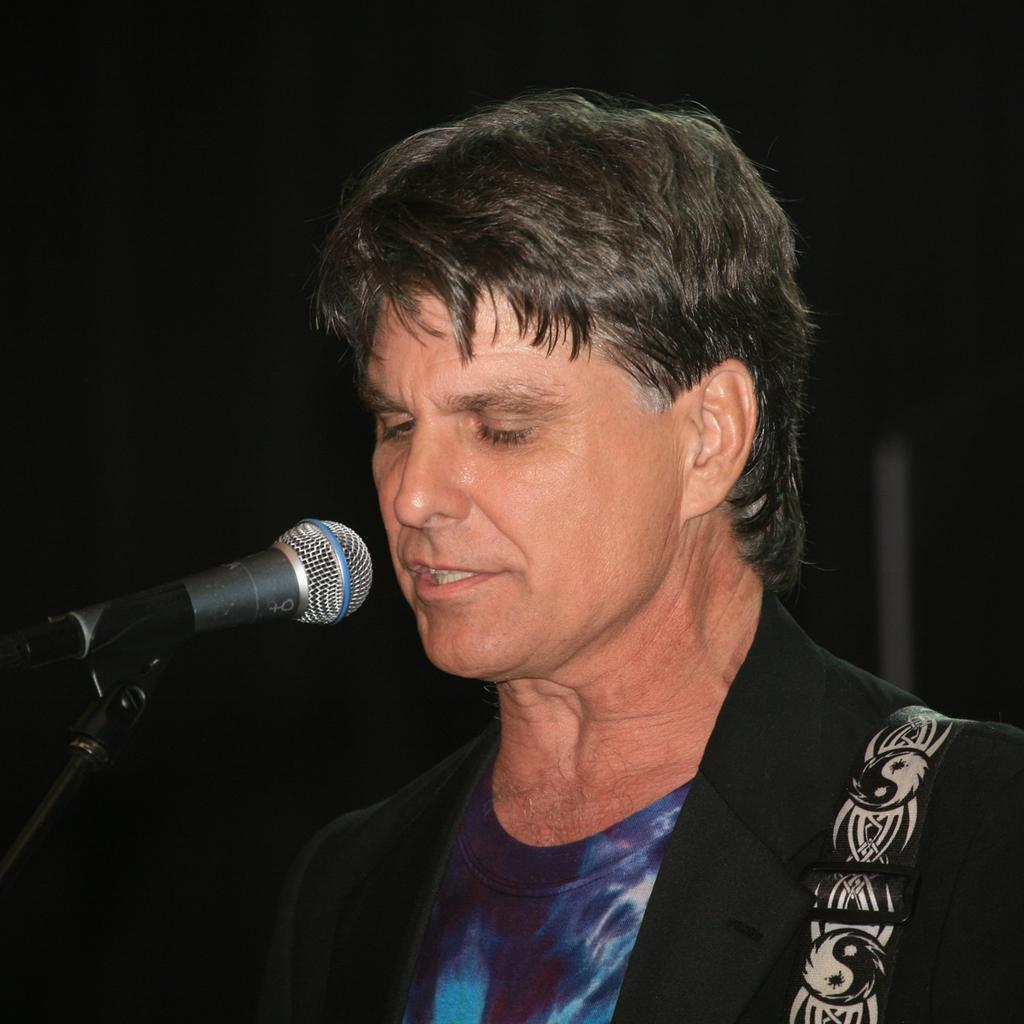How would you summarize this image in a sentence or two? In the foreground of this picture we can see a person seems to be wearing a blazer and standing. On the left we can see a microphone is attached to the metal stand. The background of the image is very dark. 